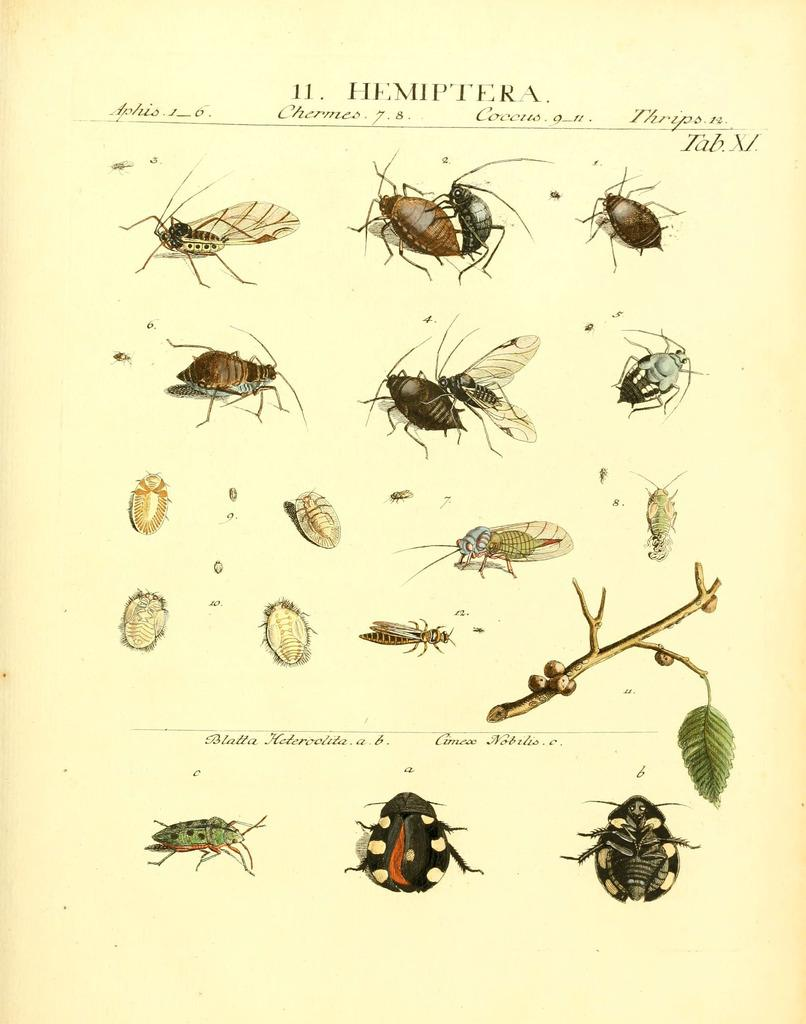What is the main subject of the image? The main subject of the image is a chart. What information does the chart display? The chart displays different types of insects. Can you name some of the insects shown on the chart? The insects on the chart include cockroaches, dragonflies, and bugs. What type of statement is being made by the boot in the image? There is no boot present in the image, so it is not possible to answer that question. 